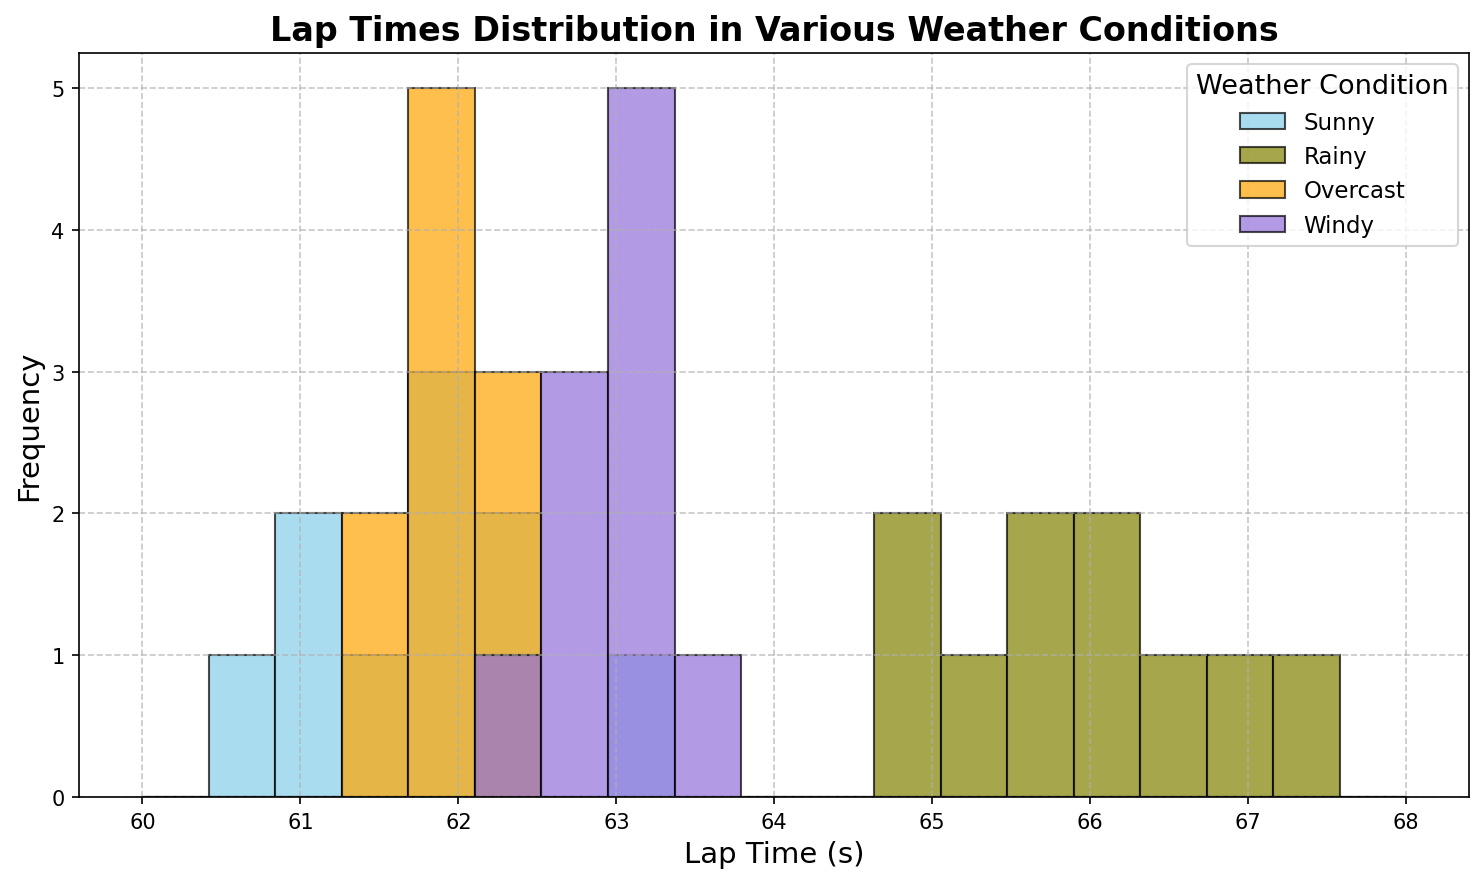What is the general trend of lap times under rainy conditions compared to sunny conditions? By examining the histogram, you'll notice that the lap times under rainy conditions are generally higher than those under sunny conditions. This indicates that racers tend to have slower lap times when it's raining.
Answer: Rainy conditions generally have higher lap times than sunny conditions Which weather condition shows the most consistent lap times? To determine consistency, look at the spread of the bins in the histogram. The condition with the narrowest lap time range represents the most consistent lap times. In this case, the overcast condition shows the narrowest distribution, indicating the most consistent lap times.
Answer: Overcast How does the variability of lap times under windy conditions compare to rainy conditions? Variability can be judged by the width of the distribution. The histogram shows the lap times under rainy conditions have a wider distribution compared to windy conditions, indicating more variability.
Answer: Rainy conditions have more variability than windy conditions Which weather condition has the highest frequency of lap times around 62 seconds? Check the histograms and focus on the bins around 62 seconds. The sunny and overcast conditions both show high frequencies of lap times around this value, with sunny marginally higher.
Answer: Sunny What is the approximate range of lap times under overcast conditions? Look at the minimum and maximum lap times in the histogram for overcast conditions. The overcast lap times range from around 61.4 to 62.5 seconds.
Answer: Approximately 61.4 to 62.5 seconds Which weather condition has the widest distribution of lap times? The widest distribution is seen by observing which histogram spans the most seconds. The rainy condition histogram spans from about 64.8 to 67.2 seconds, the widest range.
Answer: Rainy Compare the median lap time between sunny and overcast conditions. The median of the distribution is the middle value. For both sunny and overcast conditions, find the middle bin in the histogram. Sunny laps center around 61.8 and overcast around 62.0.
Answer: Overcast has a slightly higher median lap time For which weather condition is there the least overlap in lap times with other conditions? Least overlap indicates that the lap times do not coincide much with other distributions. Rainy conditions show minimal overlap due to their generally higher lap times.
Answer: Rainy In which weather condition do the lap times display the most clustering around a single value? Observing the histograms, we see the overcast and sunny conditions show tight clusters around their central values. Overcast seems more tightly clustered around 62 seconds.
Answer: Overcast 